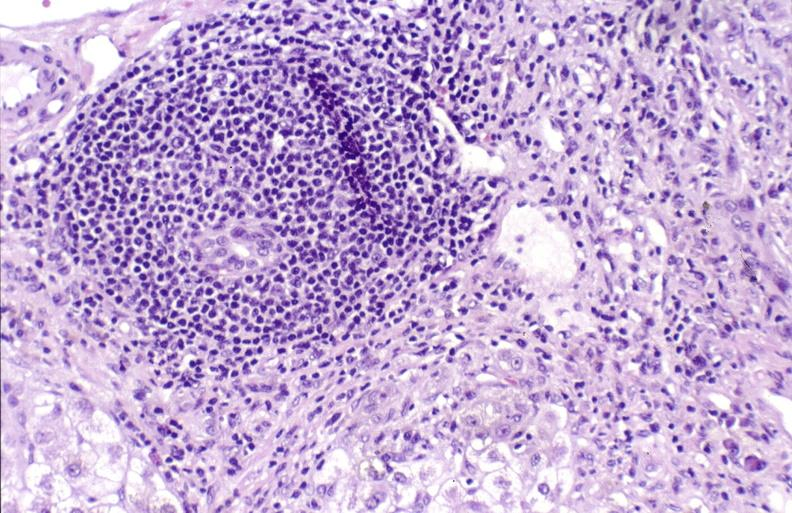s liver present?
Answer the question using a single word or phrase. Yes 